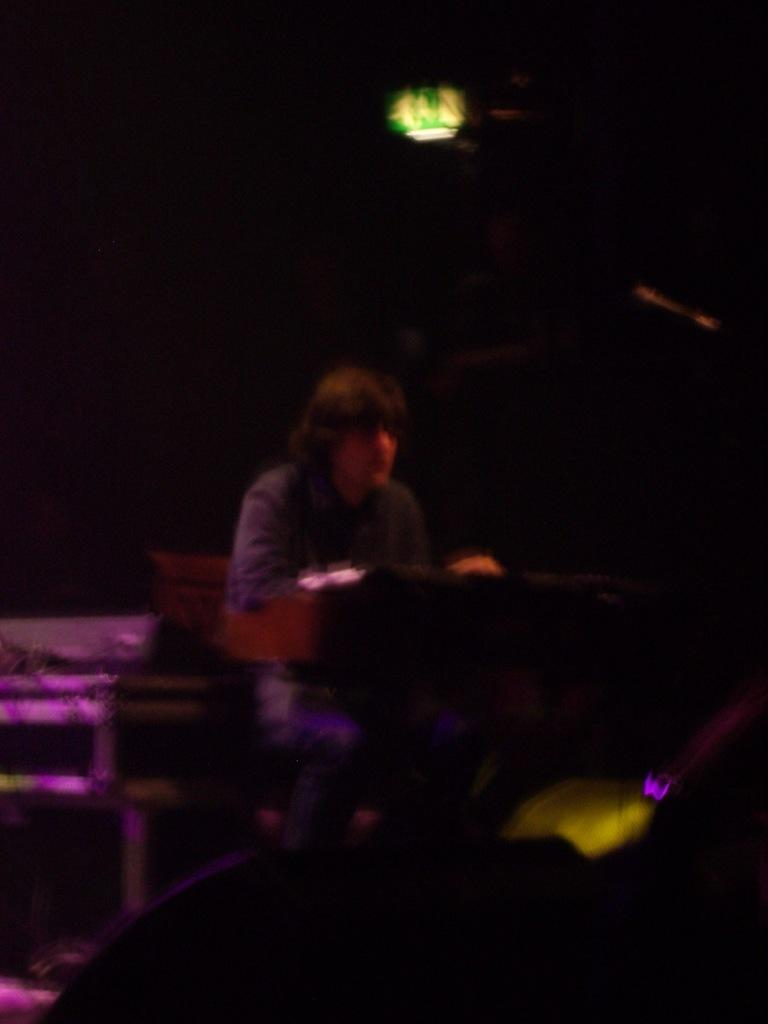What is the man in the image doing? There is a man sitting on a chair in the image. What can be seen at the top of the image? There is a light at the top in the image. How does the man in the image contribute to the mass of the Earth? The man in the image does not contribute to the mass of the Earth; his presence is negligible in comparison to the Earth's total mass. How does the light at the top increase the energy efficiency of the room in the image? The facts provided do not give any information about the energy efficiency of the room, so it cannot be determined how the light contributes to it. 